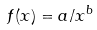Convert formula to latex. <formula><loc_0><loc_0><loc_500><loc_500>f ( x ) = a / x ^ { b }</formula> 